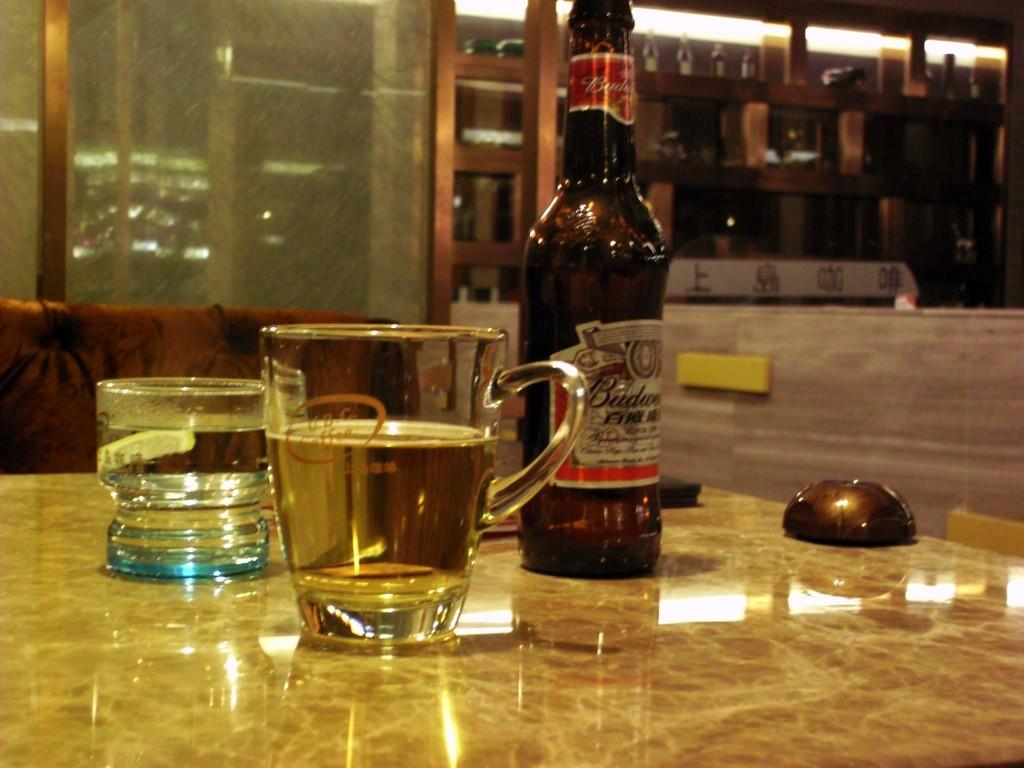<image>
Describe the image concisely. A bottle of Budweiser sits on a counter next to a couple of drinking glasses. 